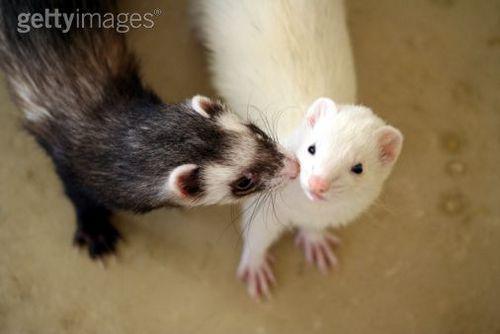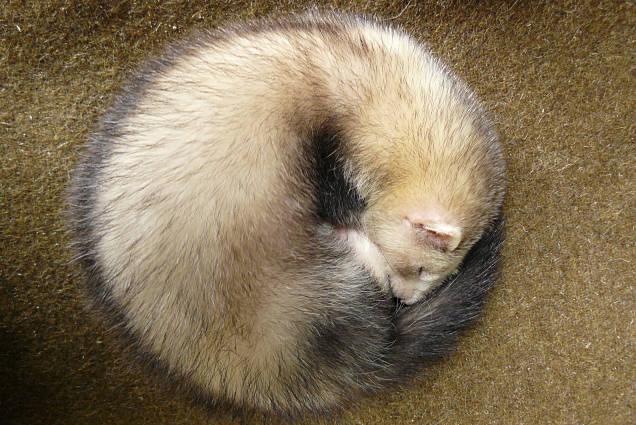The first image is the image on the left, the second image is the image on the right. Given the left and right images, does the statement "There are a total of three ferrets." hold true? Answer yes or no. Yes. 